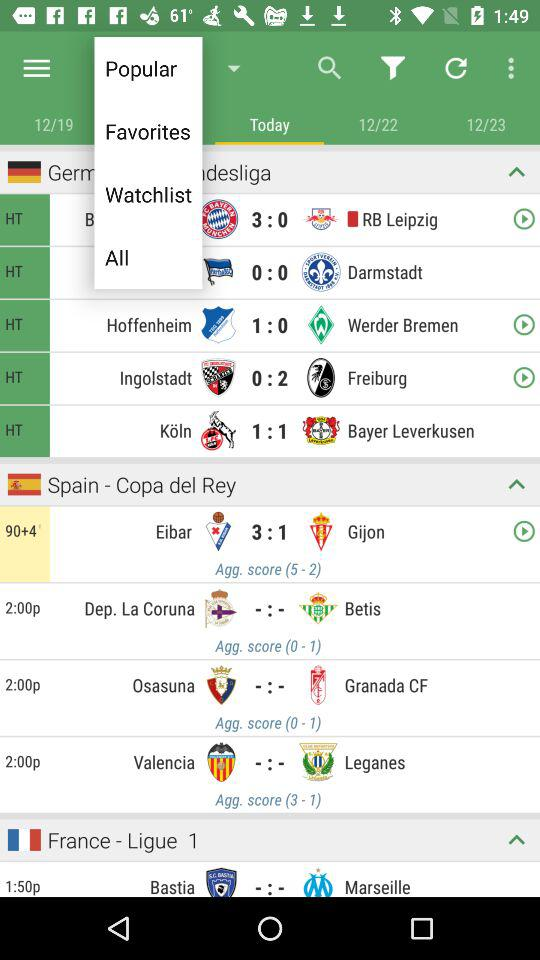How many goals did the team "Gijon" score? The team "Gijon" scored 1 goal. 